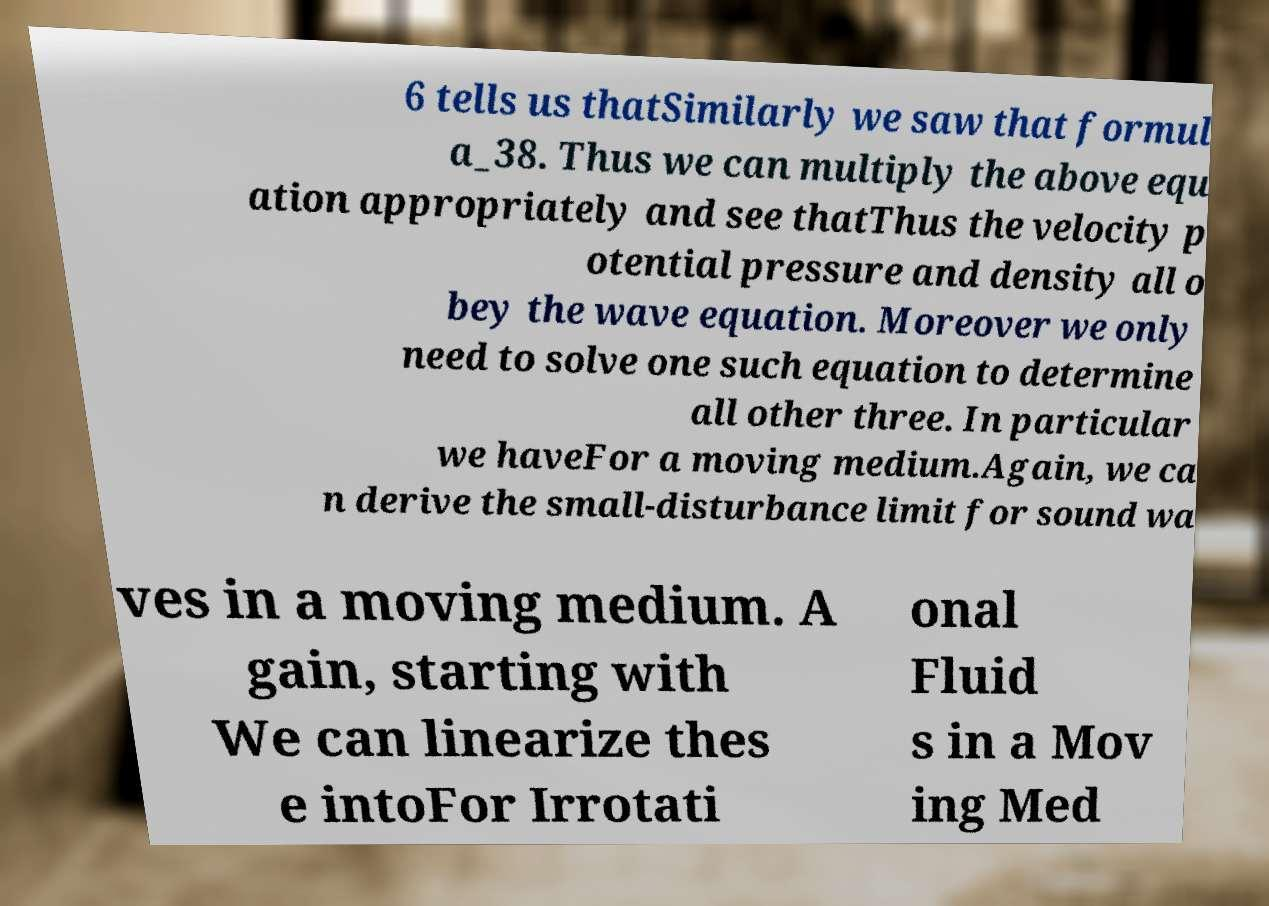There's text embedded in this image that I need extracted. Can you transcribe it verbatim? 6 tells us thatSimilarly we saw that formul a_38. Thus we can multiply the above equ ation appropriately and see thatThus the velocity p otential pressure and density all o bey the wave equation. Moreover we only need to solve one such equation to determine all other three. In particular we haveFor a moving medium.Again, we ca n derive the small-disturbance limit for sound wa ves in a moving medium. A gain, starting with We can linearize thes e intoFor Irrotati onal Fluid s in a Mov ing Med 